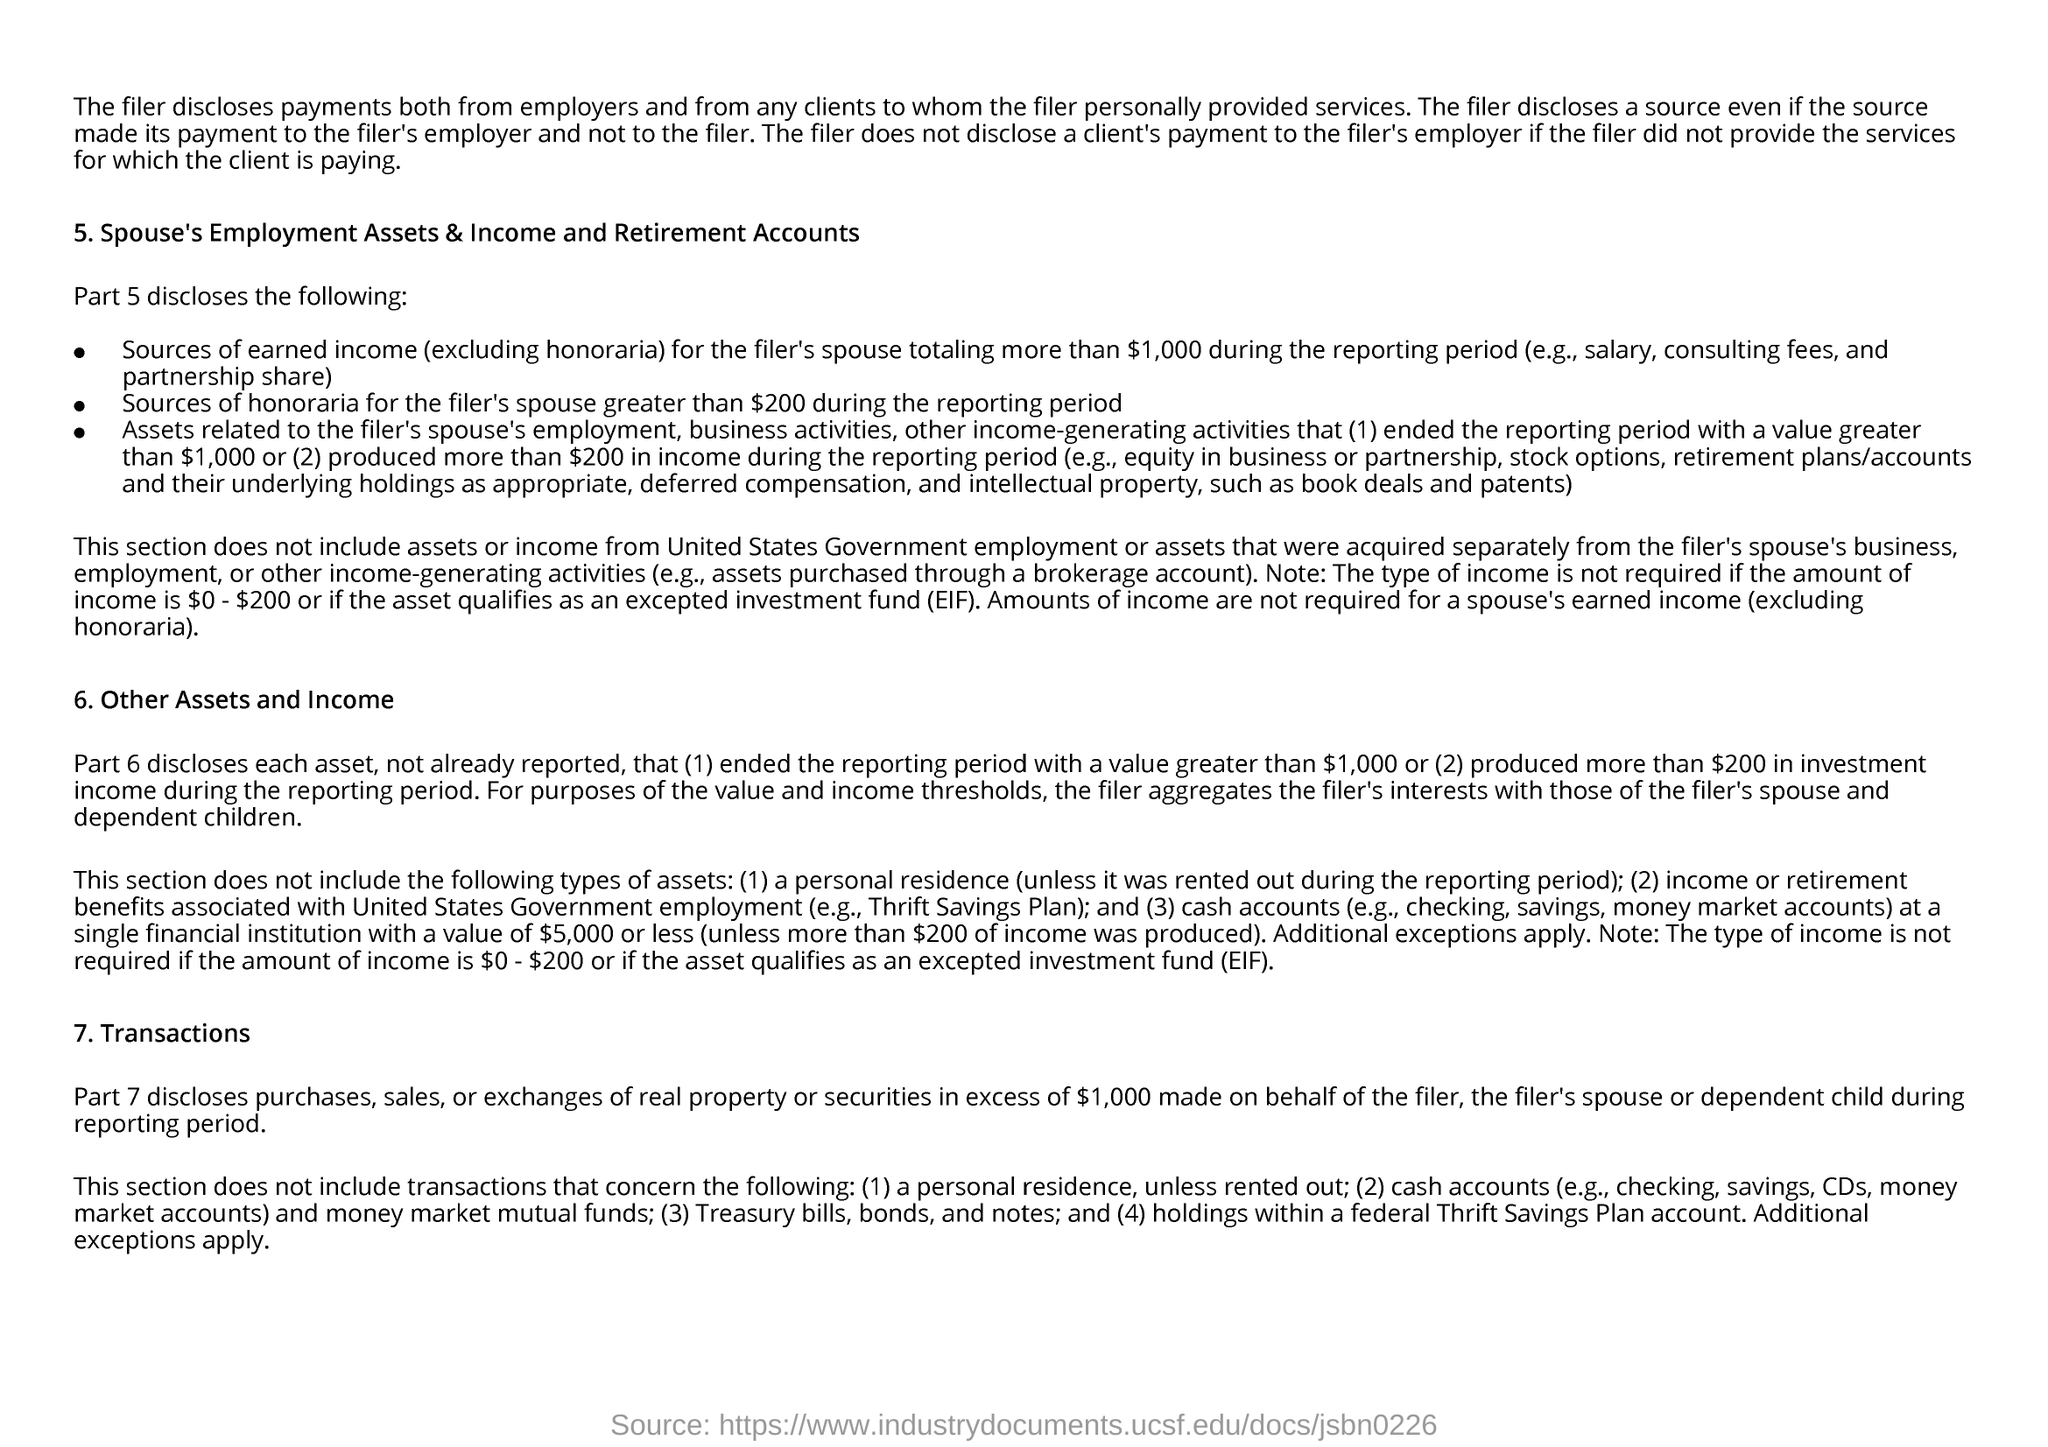Give some essential details in this illustration. EIF stands for Expected Investment Fund. The filer discloses payments from any clients to whom the filer personally provided services. 